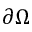Convert formula to latex. <formula><loc_0><loc_0><loc_500><loc_500>\partial \Omega</formula> 